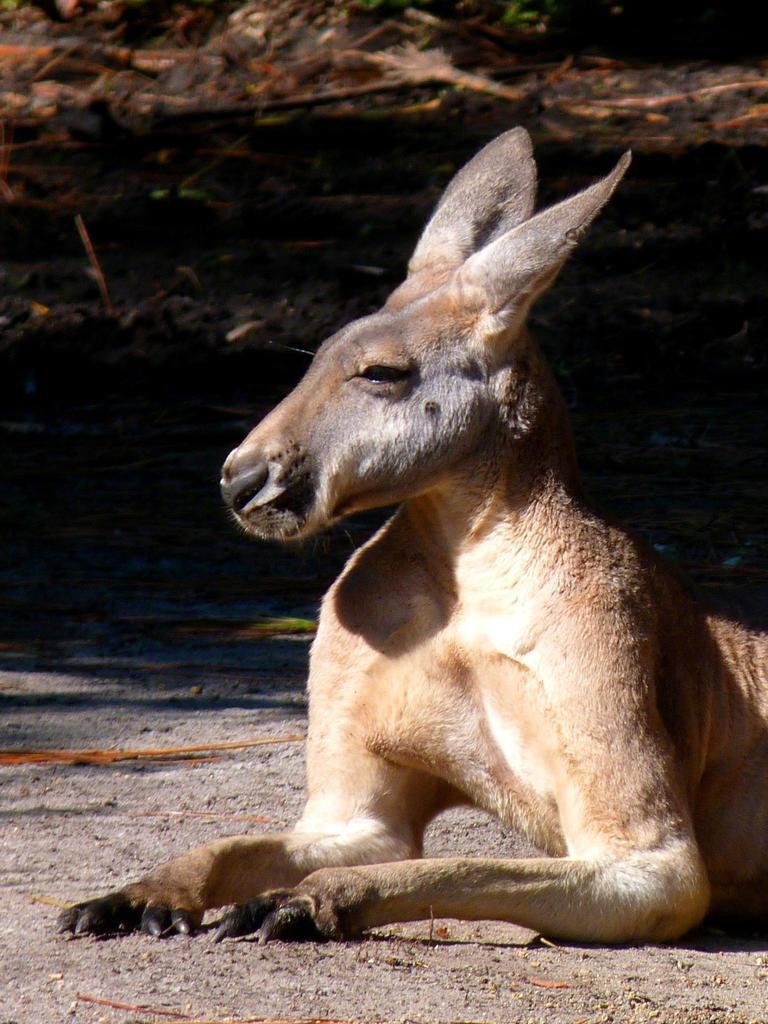Describe this image in one or two sentences. In this image there is an animal sitting on the land. 